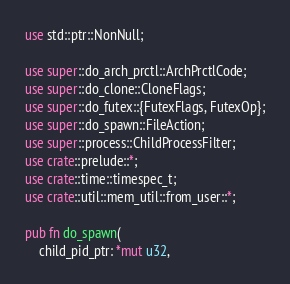<code> <loc_0><loc_0><loc_500><loc_500><_Rust_>use std::ptr::NonNull;

use super::do_arch_prctl::ArchPrctlCode;
use super::do_clone::CloneFlags;
use super::do_futex::{FutexFlags, FutexOp};
use super::do_spawn::FileAction;
use super::process::ChildProcessFilter;
use crate::prelude::*;
use crate::time::timespec_t;
use crate::util::mem_util::from_user::*;

pub fn do_spawn(
    child_pid_ptr: *mut u32,</code> 